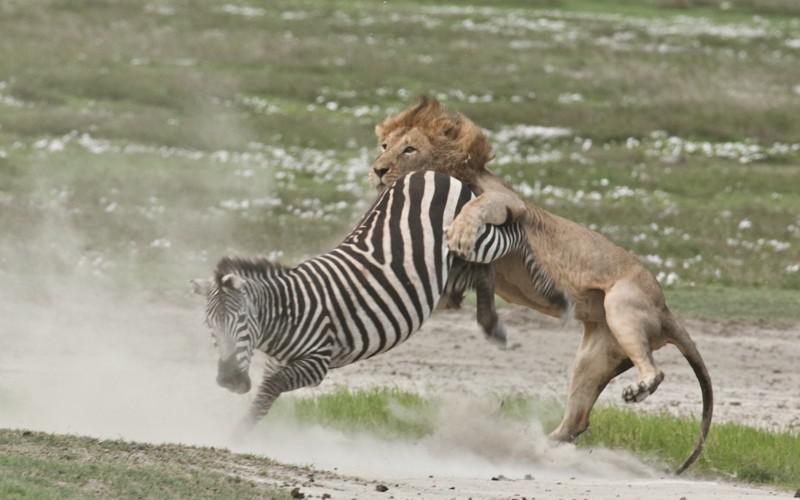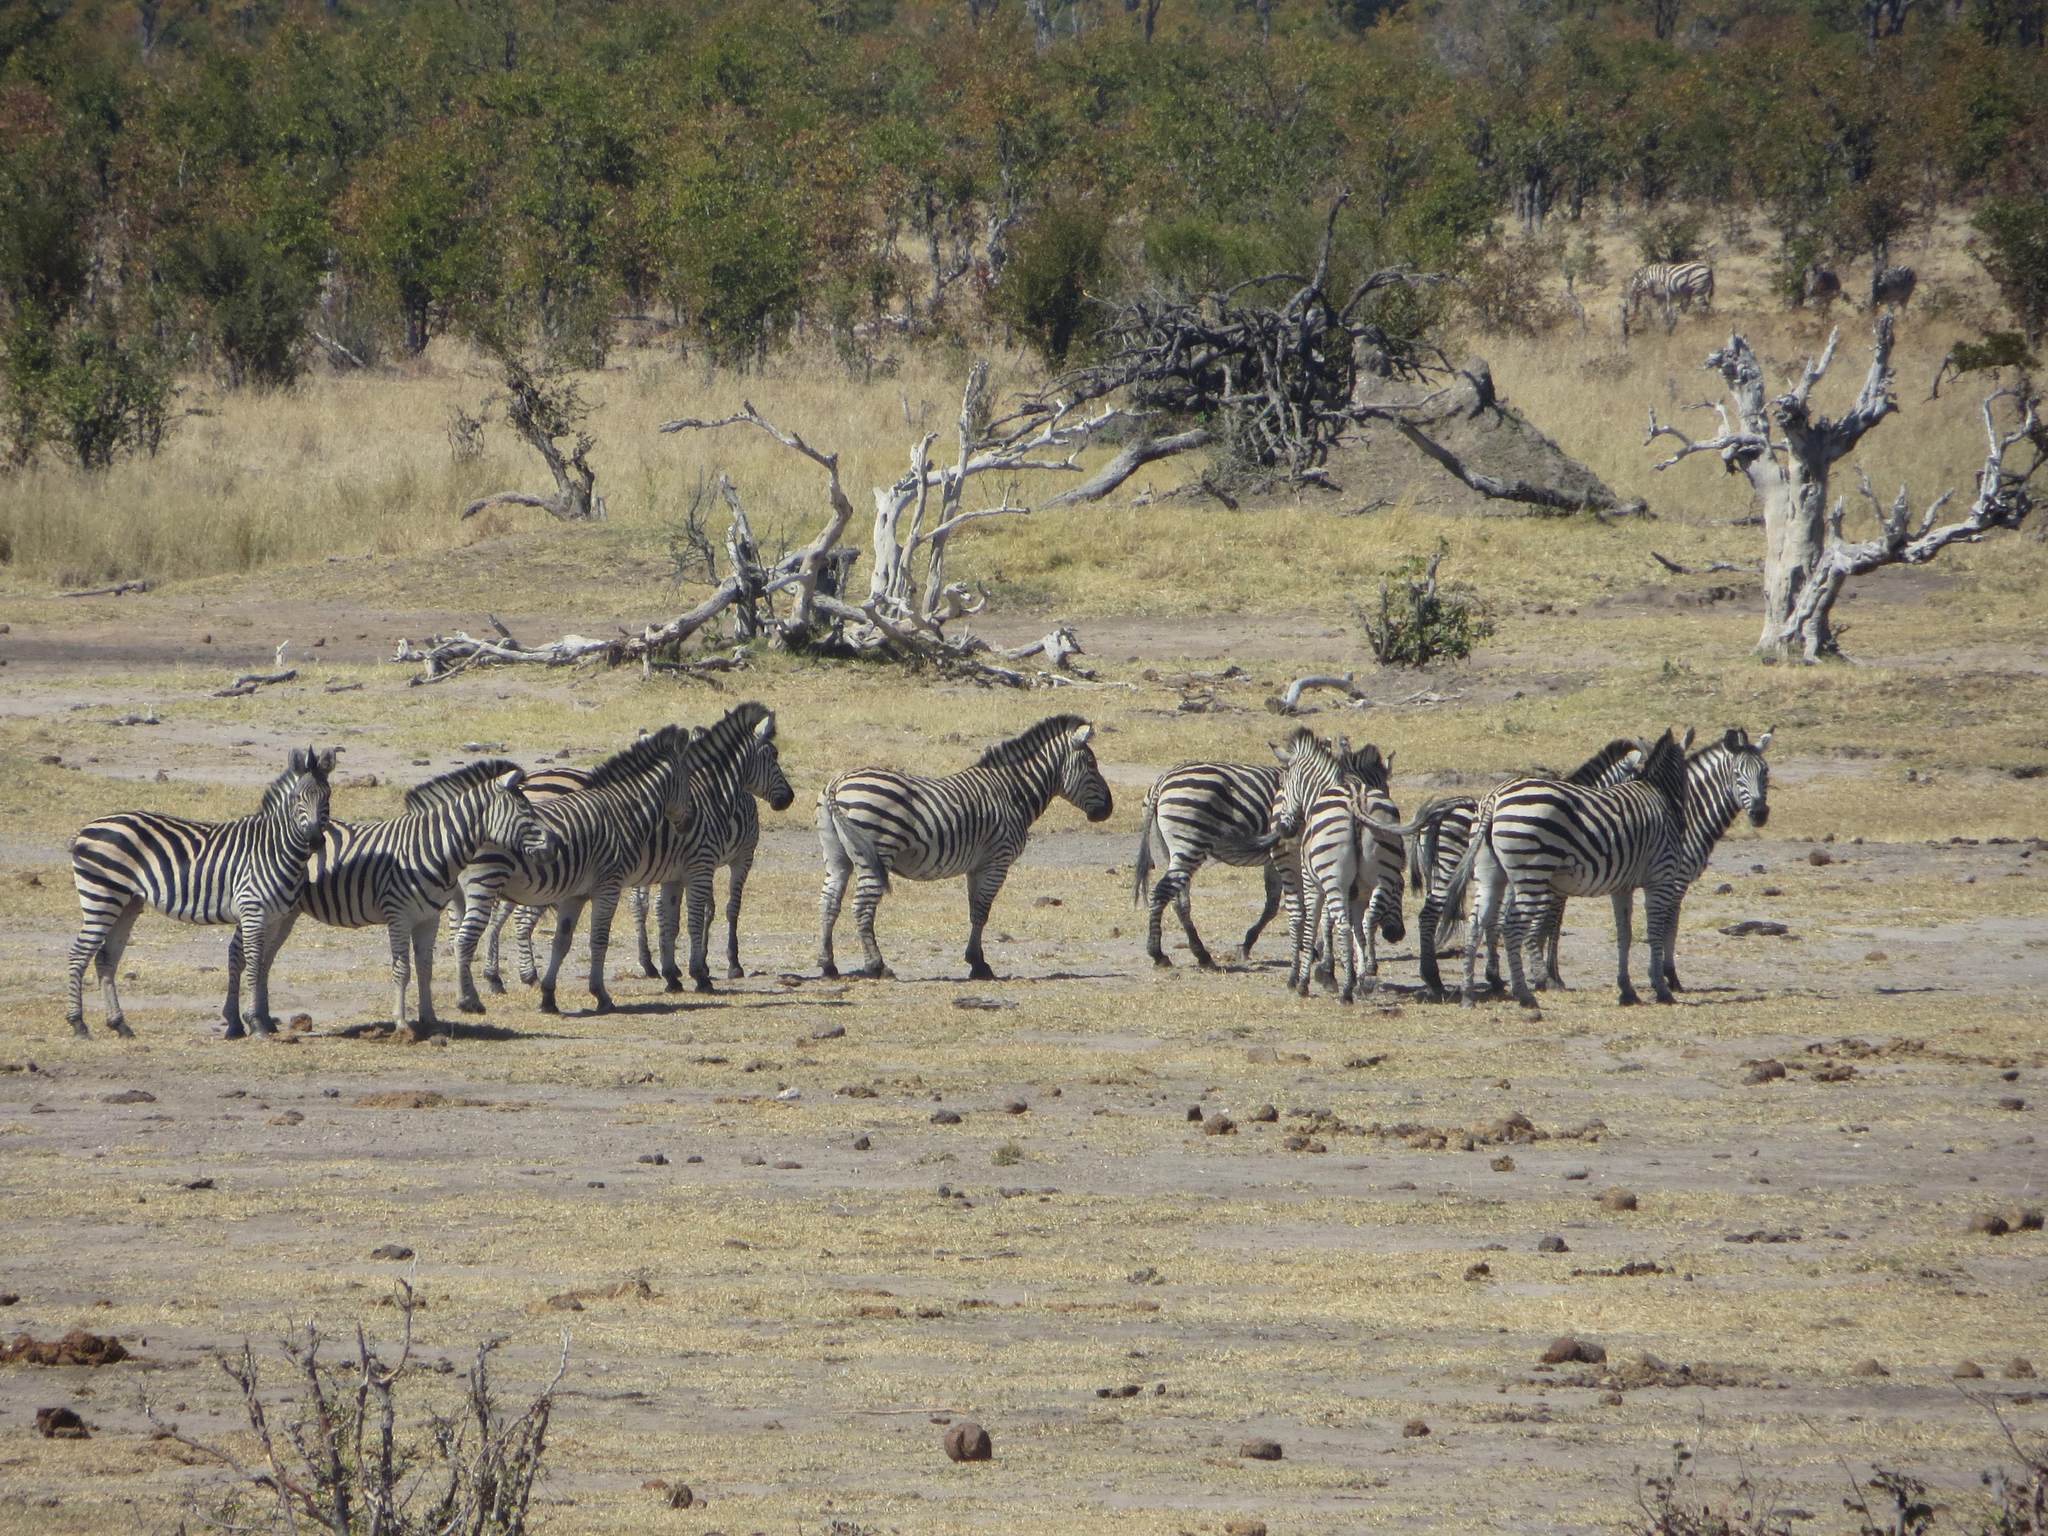The first image is the image on the left, the second image is the image on the right. Evaluate the accuracy of this statement regarding the images: "Zebras are running.". Is it true? Answer yes or no. No. The first image is the image on the left, the second image is the image on the right. For the images displayed, is the sentence "The combined images include zebra at a watering hole and a rear-facing elephant near a standing zebra." factually correct? Answer yes or no. No. 